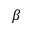<formula> <loc_0><loc_0><loc_500><loc_500>\beta</formula> 